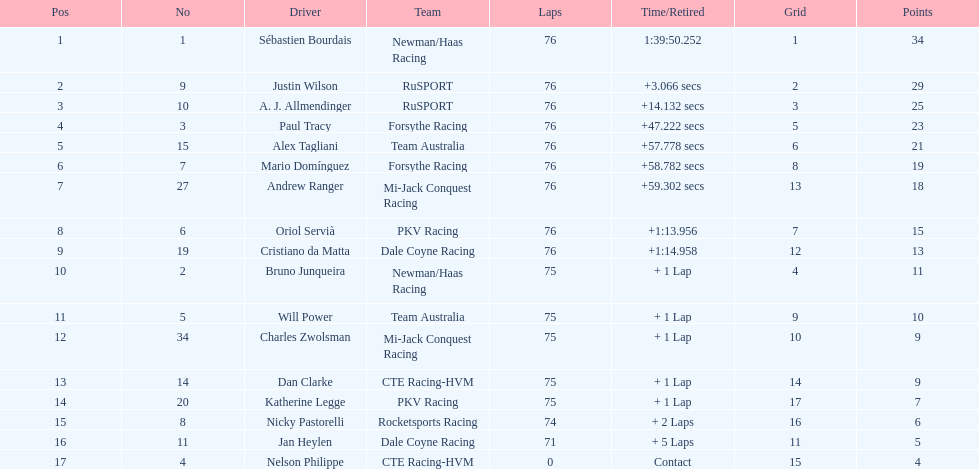What is the overall point gap between the driver with the highest points and the driver with the lowest points? 30. 